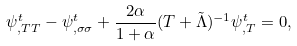Convert formula to latex. <formula><loc_0><loc_0><loc_500><loc_500>\psi ^ { t } _ { , T T } - \psi ^ { t } _ { , \sigma \sigma } + \frac { 2 \alpha } { 1 + \alpha } ( T + \tilde { \Lambda } ) ^ { - 1 } \psi ^ { t } _ { , T } = 0 ,</formula> 